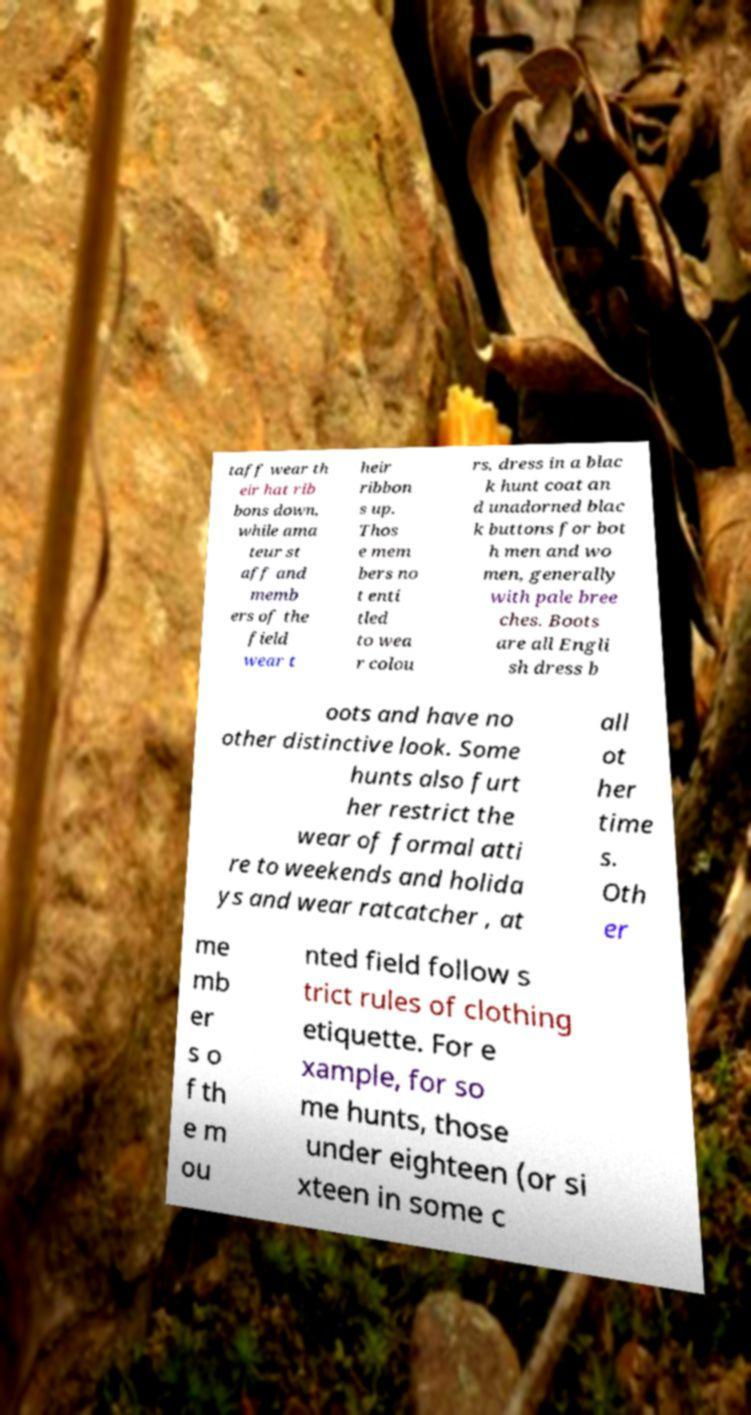Can you accurately transcribe the text from the provided image for me? taff wear th eir hat rib bons down, while ama teur st aff and memb ers of the field wear t heir ribbon s up. Thos e mem bers no t enti tled to wea r colou rs, dress in a blac k hunt coat an d unadorned blac k buttons for bot h men and wo men, generally with pale bree ches. Boots are all Engli sh dress b oots and have no other distinctive look. Some hunts also furt her restrict the wear of formal atti re to weekends and holida ys and wear ratcatcher , at all ot her time s. Oth er me mb er s o f th e m ou nted field follow s trict rules of clothing etiquette. For e xample, for so me hunts, those under eighteen (or si xteen in some c 